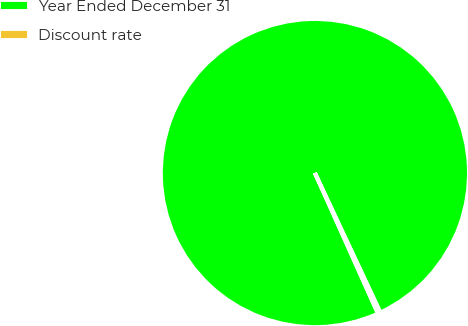<chart> <loc_0><loc_0><loc_500><loc_500><pie_chart><fcel>Year Ended December 31<fcel>Discount rate<nl><fcel>99.72%<fcel>0.28%<nl></chart> 